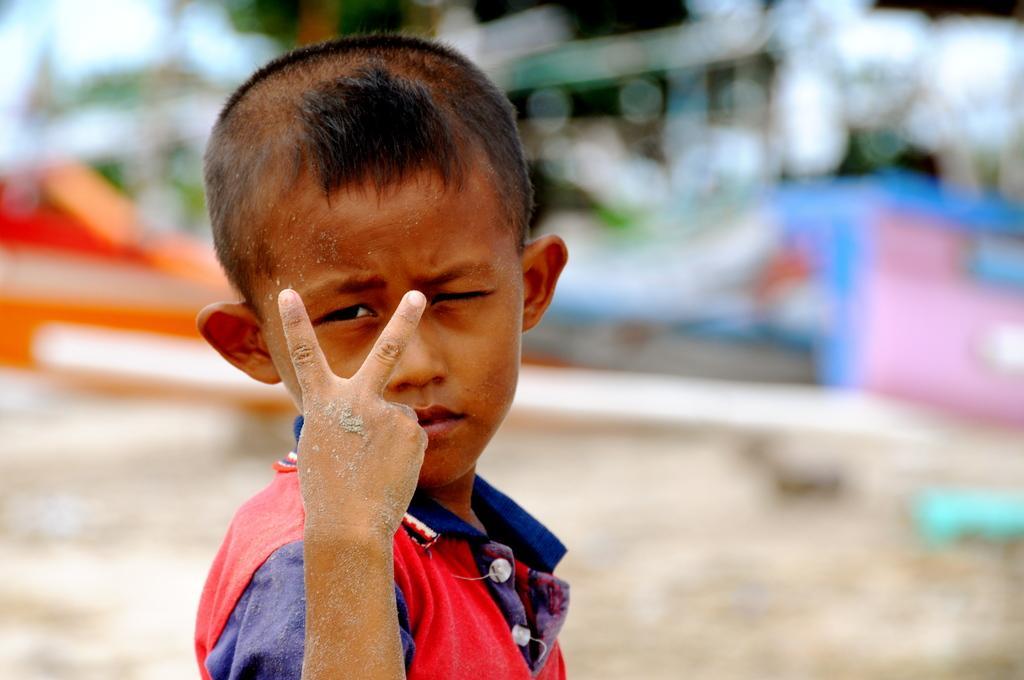In one or two sentences, can you explain what this image depicts? In the image we can see a boy wearing clothes and he is showing two fingers, and the background is blurred. 